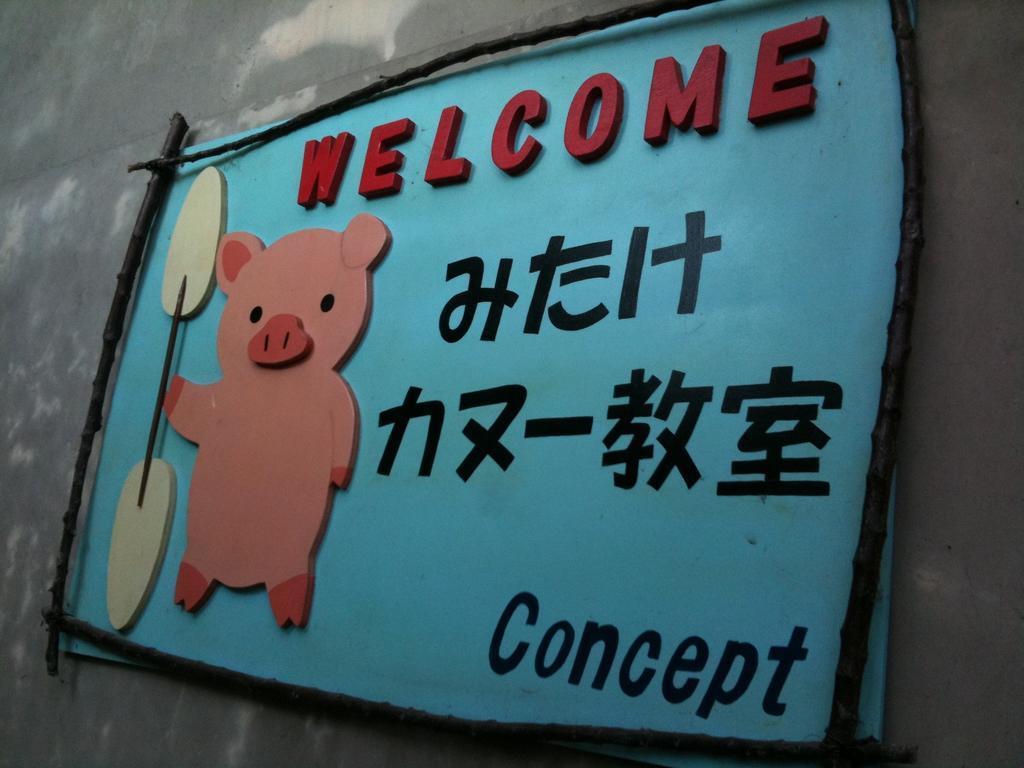Please provide a concise description of this image. In the image we can see there is a cement wall on which there is a banner and its written ¨Welcome¨ and ¨Concept¨ on it. There is a pig standing in the banner and holding a paddle in his hand. 